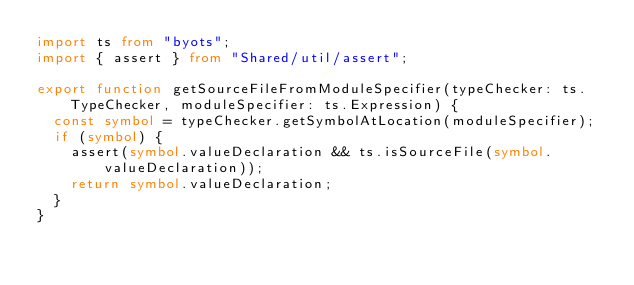Convert code to text. <code><loc_0><loc_0><loc_500><loc_500><_TypeScript_>import ts from "byots";
import { assert } from "Shared/util/assert";

export function getSourceFileFromModuleSpecifier(typeChecker: ts.TypeChecker, moduleSpecifier: ts.Expression) {
	const symbol = typeChecker.getSymbolAtLocation(moduleSpecifier);
	if (symbol) {
		assert(symbol.valueDeclaration && ts.isSourceFile(symbol.valueDeclaration));
		return symbol.valueDeclaration;
	}
}
</code> 